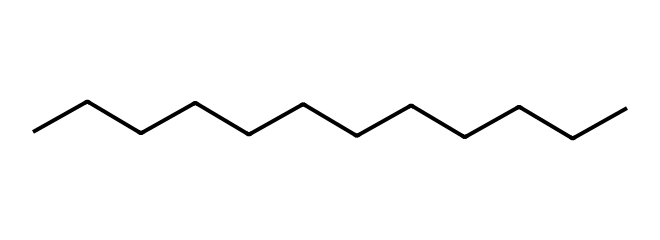What is the carbon chain length of this molecule? The SMILES representation indicates 12 consecutive carbon atoms (CCCCCCCCCCCC), which means the carbon chain length is determined by counting the number of "C" characters in the series.
Answer: twelve How many hydrogen atoms are associated with this chemical? This molecule represents a typical alkane where the formula is CnH(2n+2). For 12 carbon atoms, the number of hydrogen atoms can be calculated as: H = 2(12) + 2 = 26.
Answer: twenty-six What type of hydrocarbon is represented by this molecule? This chemical structure, which contains only carbon and hydrogen atoms with single bonds, classifies it as an alkane.
Answer: alkane What is the molecular formula of this chemical? The structure has 12 carbon atoms and 26 hydrogen atoms, giving the molecular formula C12H26 based on the count of each atom from the SMILES representation.
Answer: C12H26 Does this molecule contain any functional groups? Analyzing the given structure shows only carbon and hydrogen atoms connected by single bonds, indicating that there are no functional groups present.
Answer: no What is the saturation level of this hydrocarbon? The presence of only single bonds and the total number of hydrogen atoms confirms that this molecule is completely saturated, meaning all carbon atoms have the maximum number of hydrogen atoms attached.
Answer: saturated Is this compound likely to be a liquid at room temperature? The structure indicates that it is a larger alkane and alkanes of this carbon chain length (12) are typically in the liquid state at room temperature due to their molecular weight and structure.
Answer: likely 